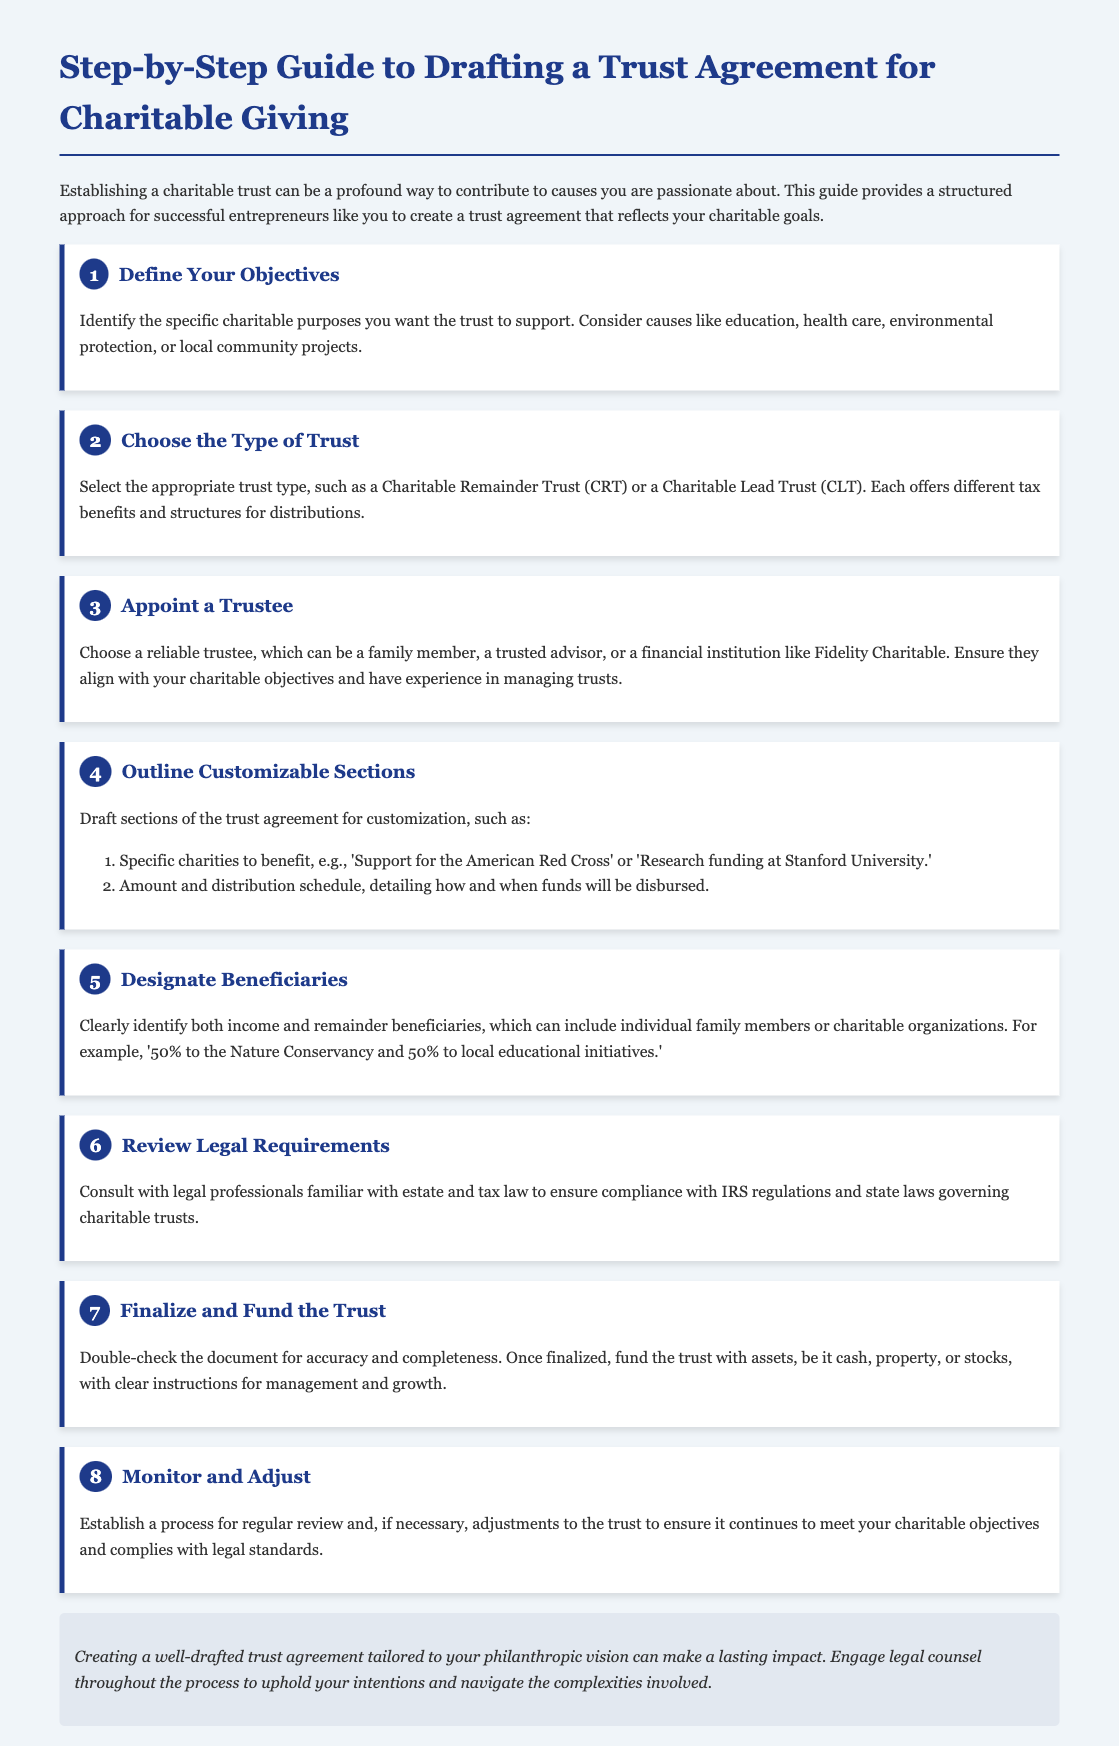what is the title of the document? The title is explicitly stated in the document as the main heading.
Answer: Step-by-Step Guide to Drafting a Trust Agreement for Charitable Giving how many steps are outlined in the guide? The number of steps is indicated by the headings and the structure of the document.
Answer: 8 what is the first step in drafting a trust agreement? The first step is mentioned in the steps section as the initial action to take.
Answer: Define Your Objectives which type of trust is mentioned as an option? The specific type of trust is stated in the second step of the guide.
Answer: Charitable Remainder Trust who should be appointed as a trustee according to the guide? The document specifies whom you can choose to appoint in the third step.
Answer: A reliable trustee what should you outline in customizable sections? The document lists specific areas for customization in step four.
Answer: Specific charities to benefit what is required before finalizing the trust? The step focuses on what needs to be done before funding the trust in the seventh step.
Answer: Review legal requirements what is the conclusion about creating a trust agreement? The conclusion summarizes the importance and the recommendation regarding legal counsel.
Answer: Lasting impact and legal counsel 